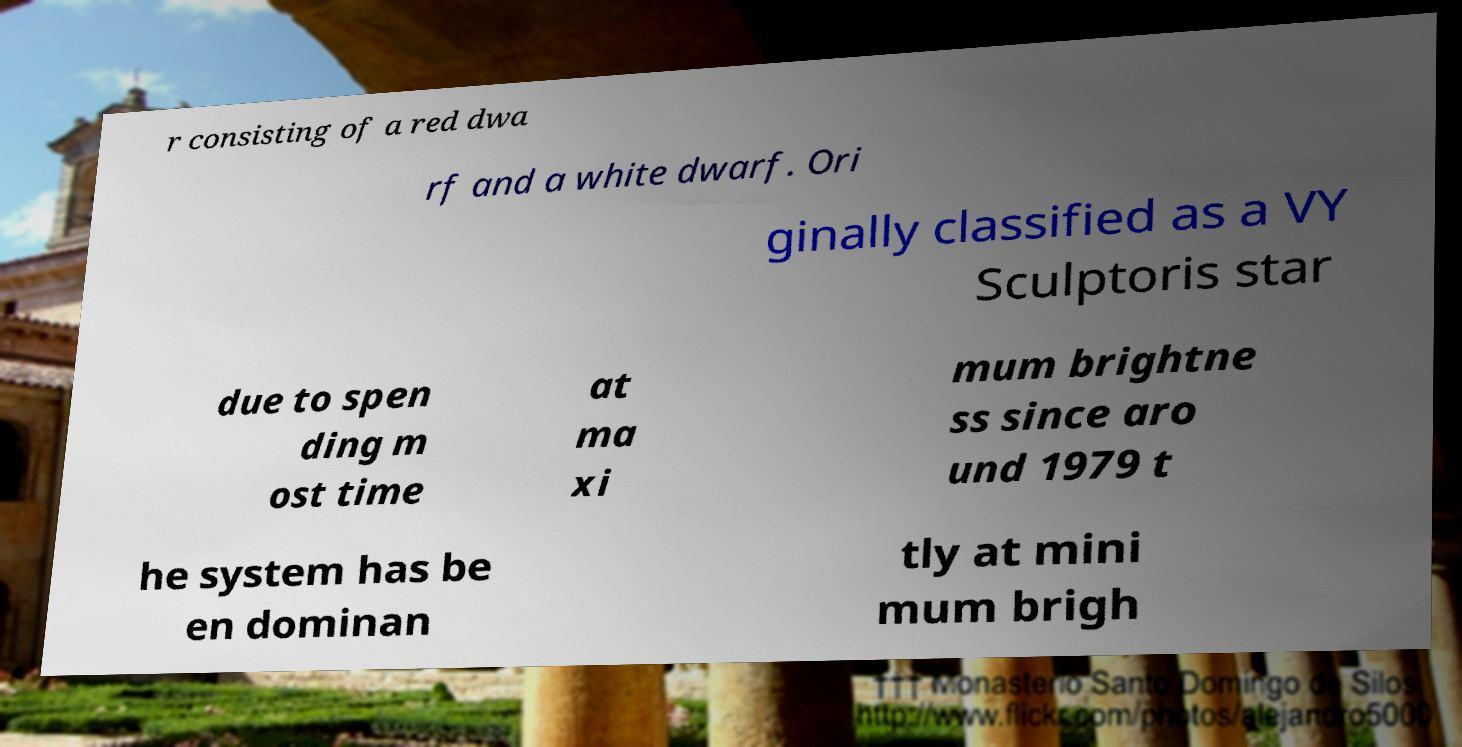Please identify and transcribe the text found in this image. r consisting of a red dwa rf and a white dwarf. Ori ginally classified as a VY Sculptoris star due to spen ding m ost time at ma xi mum brightne ss since aro und 1979 t he system has be en dominan tly at mini mum brigh 